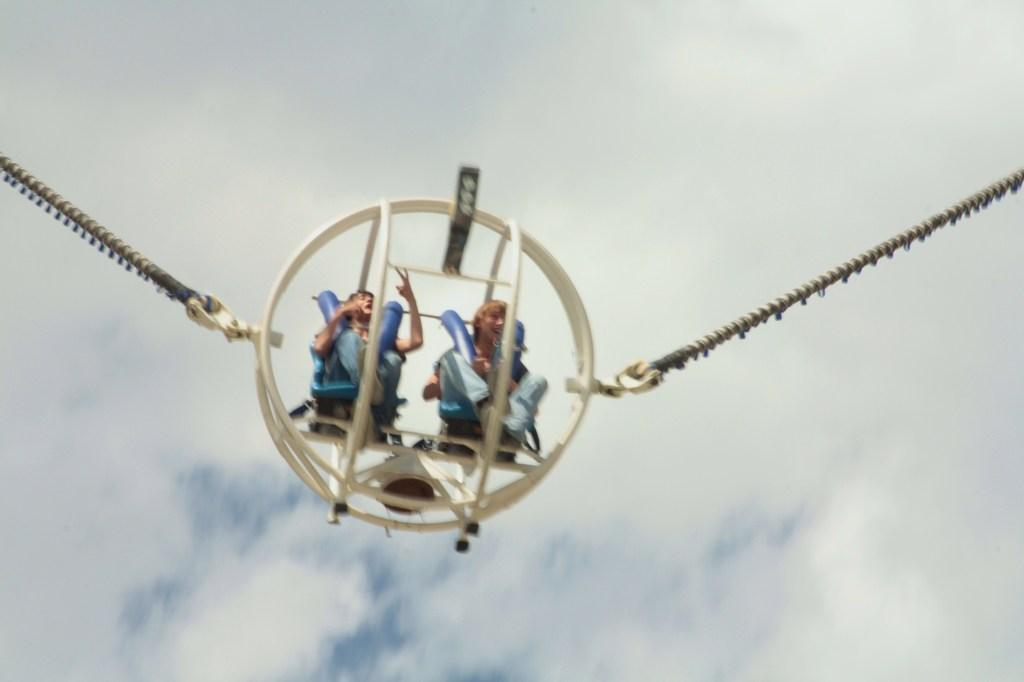How many people are in the image? There are two people in the image. What are the people doing in the image? The people are sitting on a ride. Are there any ropes visible in the image? Yes, there are ropes attached to the ride. What can be seen in the background of the image? There are clouds and the sky visible in the background of the image. What type of cabbage is being fact-checked in the image? There is no cabbage or fact-checking activity present in the image. How many people are needed to pull the ride in the image? The image does not show anyone pulling the ride, and there are no ropes being pulled by people. 